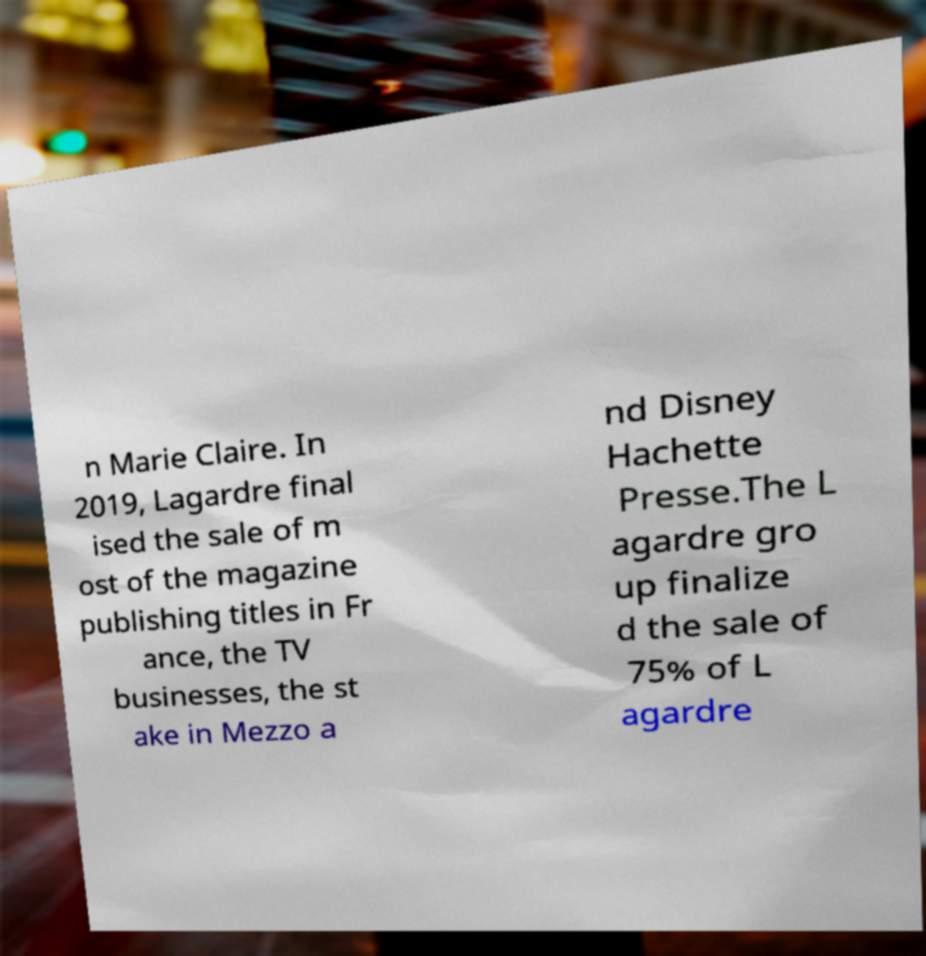For documentation purposes, I need the text within this image transcribed. Could you provide that? n Marie Claire. In 2019, Lagardre final ised the sale of m ost of the magazine publishing titles in Fr ance, the TV businesses, the st ake in Mezzo a nd Disney Hachette Presse.The L agardre gro up finalize d the sale of 75% of L agardre 